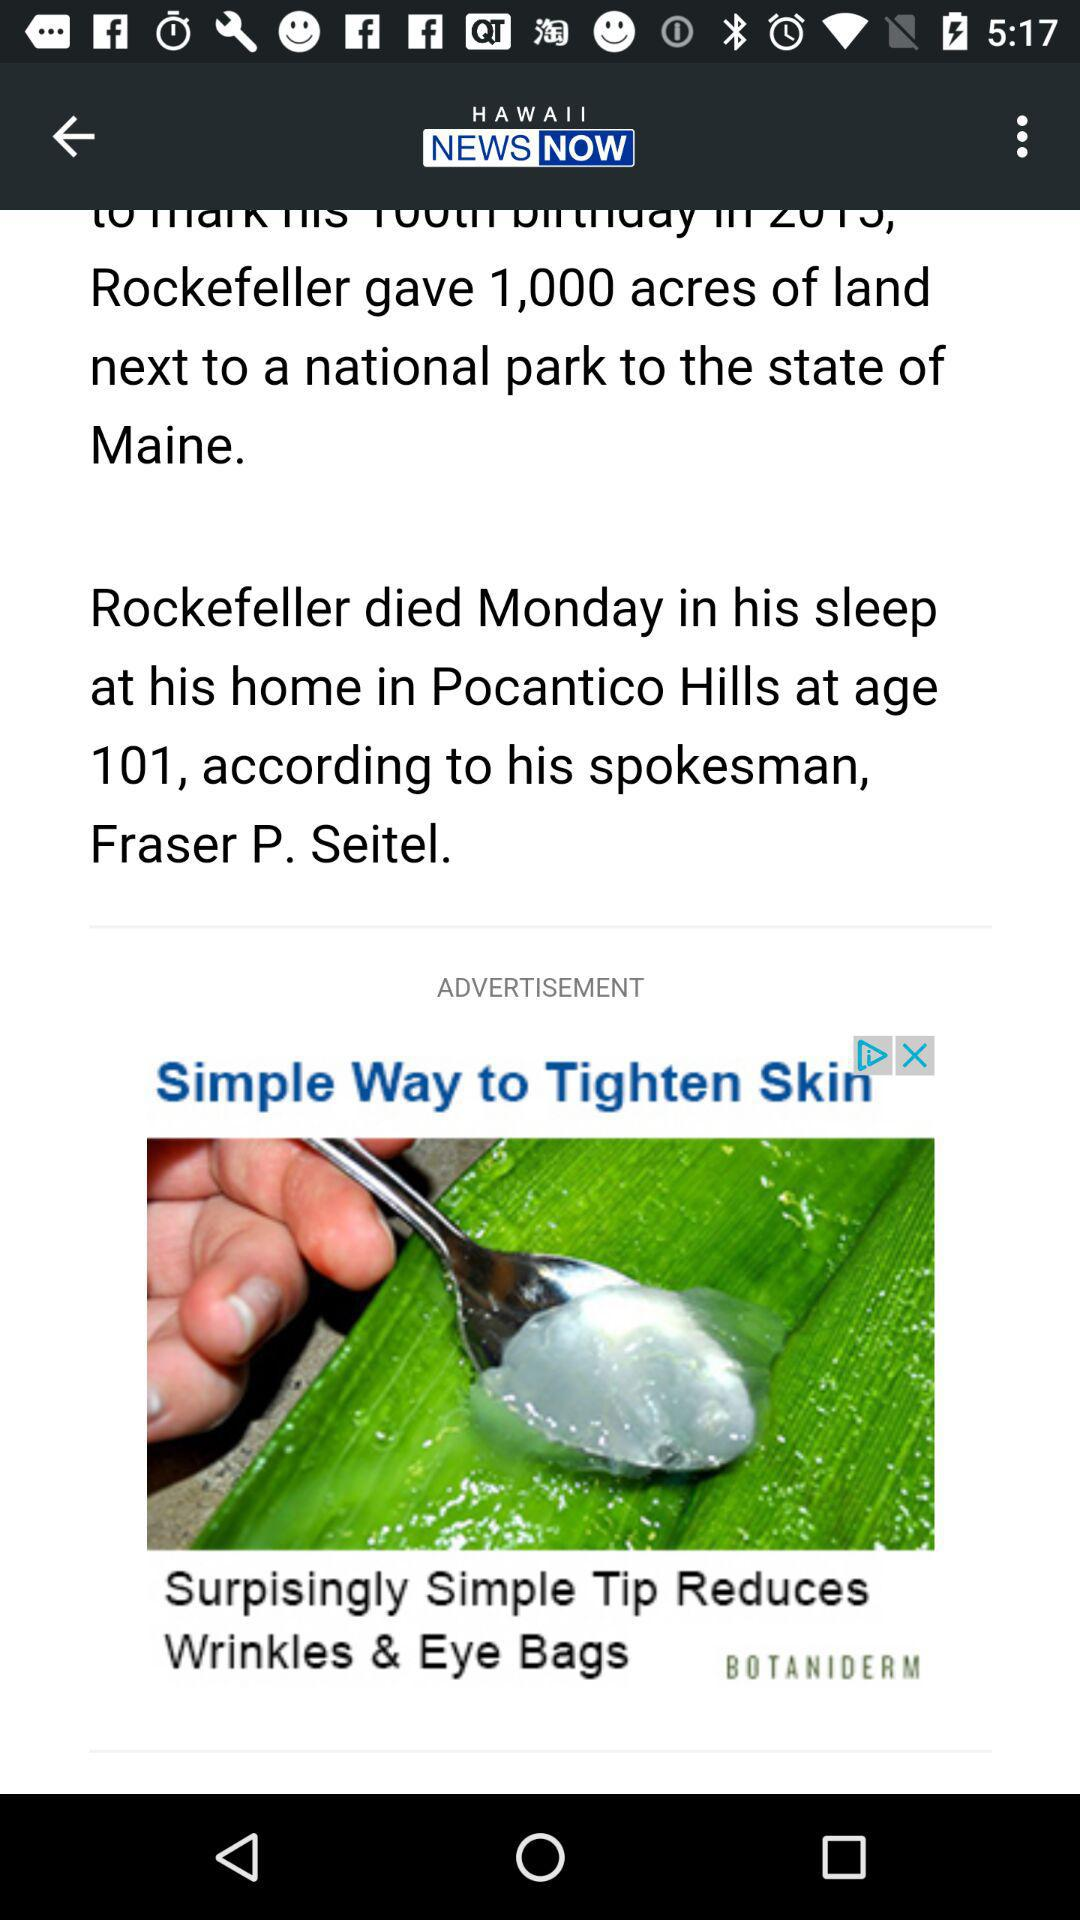What is the name of the application? The name of the application is "HAWAII NEWS NOW". 